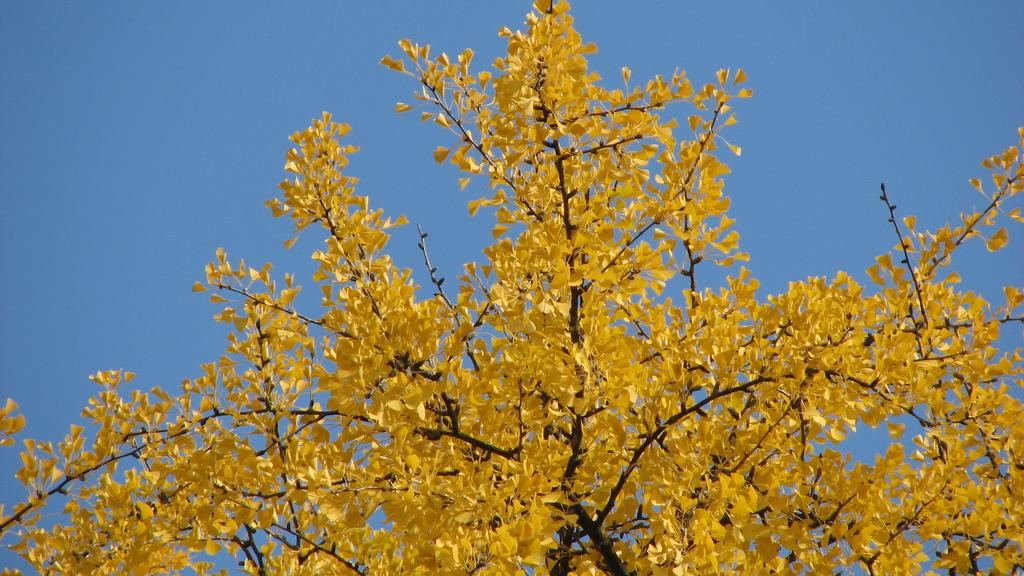What type of plant can be seen in the image? There is a tree in the image. What part of the natural environment is visible in the image? The sky is visible in the background of the image. What type of beef is being cooked on the grill in the image? There is no grill or beef present in the image; it only features a tree and the sky. What color is the banana hanging from the tree in the image? There is no banana present in the image; it only features a tree and the sky. 